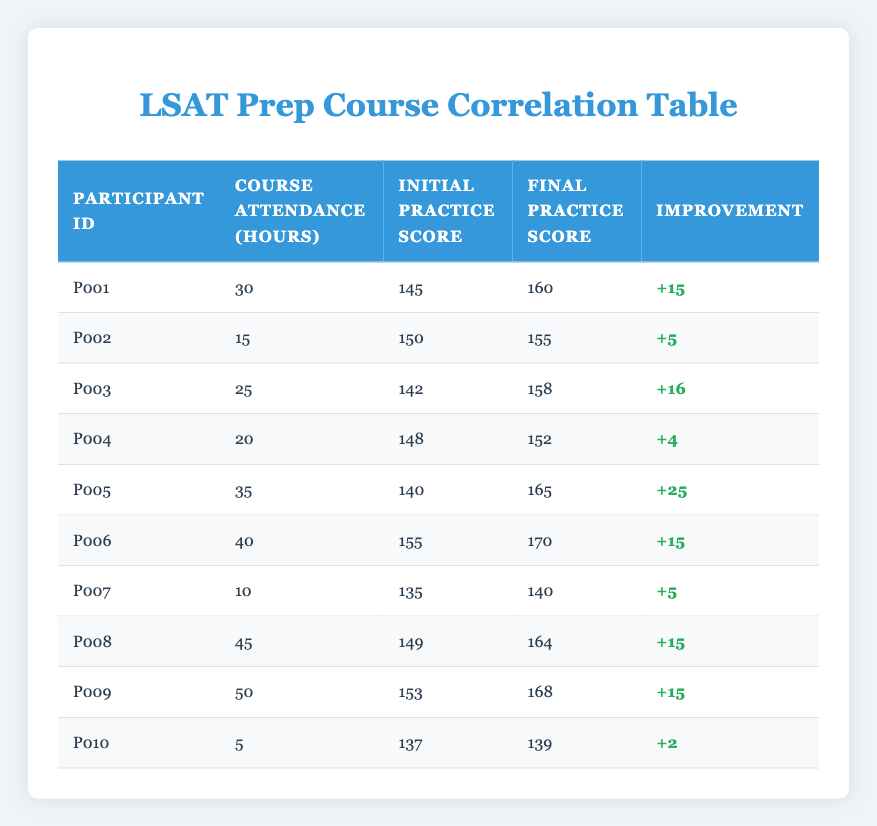What is the highest improvement in practice scores? To find the highest improvement, we look at the "Improvement" column in the table. The maximum value there is +25 for Participant P005, whose scores improved from 140 to 165.
Answer: +25 How many hours did Participant P008 attend the prep course? By checking the table, we see that Participant P008 attended the prep course for 45 hours.
Answer: 45 What is the average initial practice score of all participants? We sum the Initial Practice Scores: (145 + 150 + 142 + 148 + 140 + 155 + 135 + 149 + 153 + 137) = 1454. There are 10 participants, so the average is 1454/10 = 145.4.
Answer: 145.4 Did Participant P010 show any improvement in their practice score? Checking the improvement for Participant P010 reveals that their initial score was 137, and their final score was 139, resulting in an improvement of +2. Thus, they did show some improvement.
Answer: Yes What is the total attendance hours of participants who improved their scores by 15 points or more? First, we identify participants with an improvement of 15 or more: P001 (+15), P003 (+16), P005 (+25), P006 (+15), P008 (+15), and P009 (+15). Their attendance hours are: P001 (30), P003 (25), P005 (35), P006 (40), P008 (45), and P009 (50). Summing these hours gives 30 + 25 + 35 + 40 + 45 + 50 = 225.
Answer: 225 Which participant had the lowest initial practice score? By scanning the "Initial Practice Score" column, we identify that Participant P007 has the lowest score of 135.
Answer: P007 What percentage of participants attended the course for more than 30 hours? There are 10 participants in total. The participants who attended for more than 30 hours are P005 (35), P006 (40), P008 (45), and P009 (50), which counts as 4 participants. The percentage is (4/10) * 100% = 40%.
Answer: 40% Which participant experienced the smallest improvement? Looking through the "Improvement" column, the smallest increase is +2 for Participant P010.
Answer: P010 Did all participants who attended for more than 30 hours also improve their scores? Reviewing the participants with over 30 hours: P005 (+25), P006 (+15), P008 (+15), and P009 (+15) shows all had improvements. Therefore, it is true that all these participants improved their scores.
Answer: Yes 